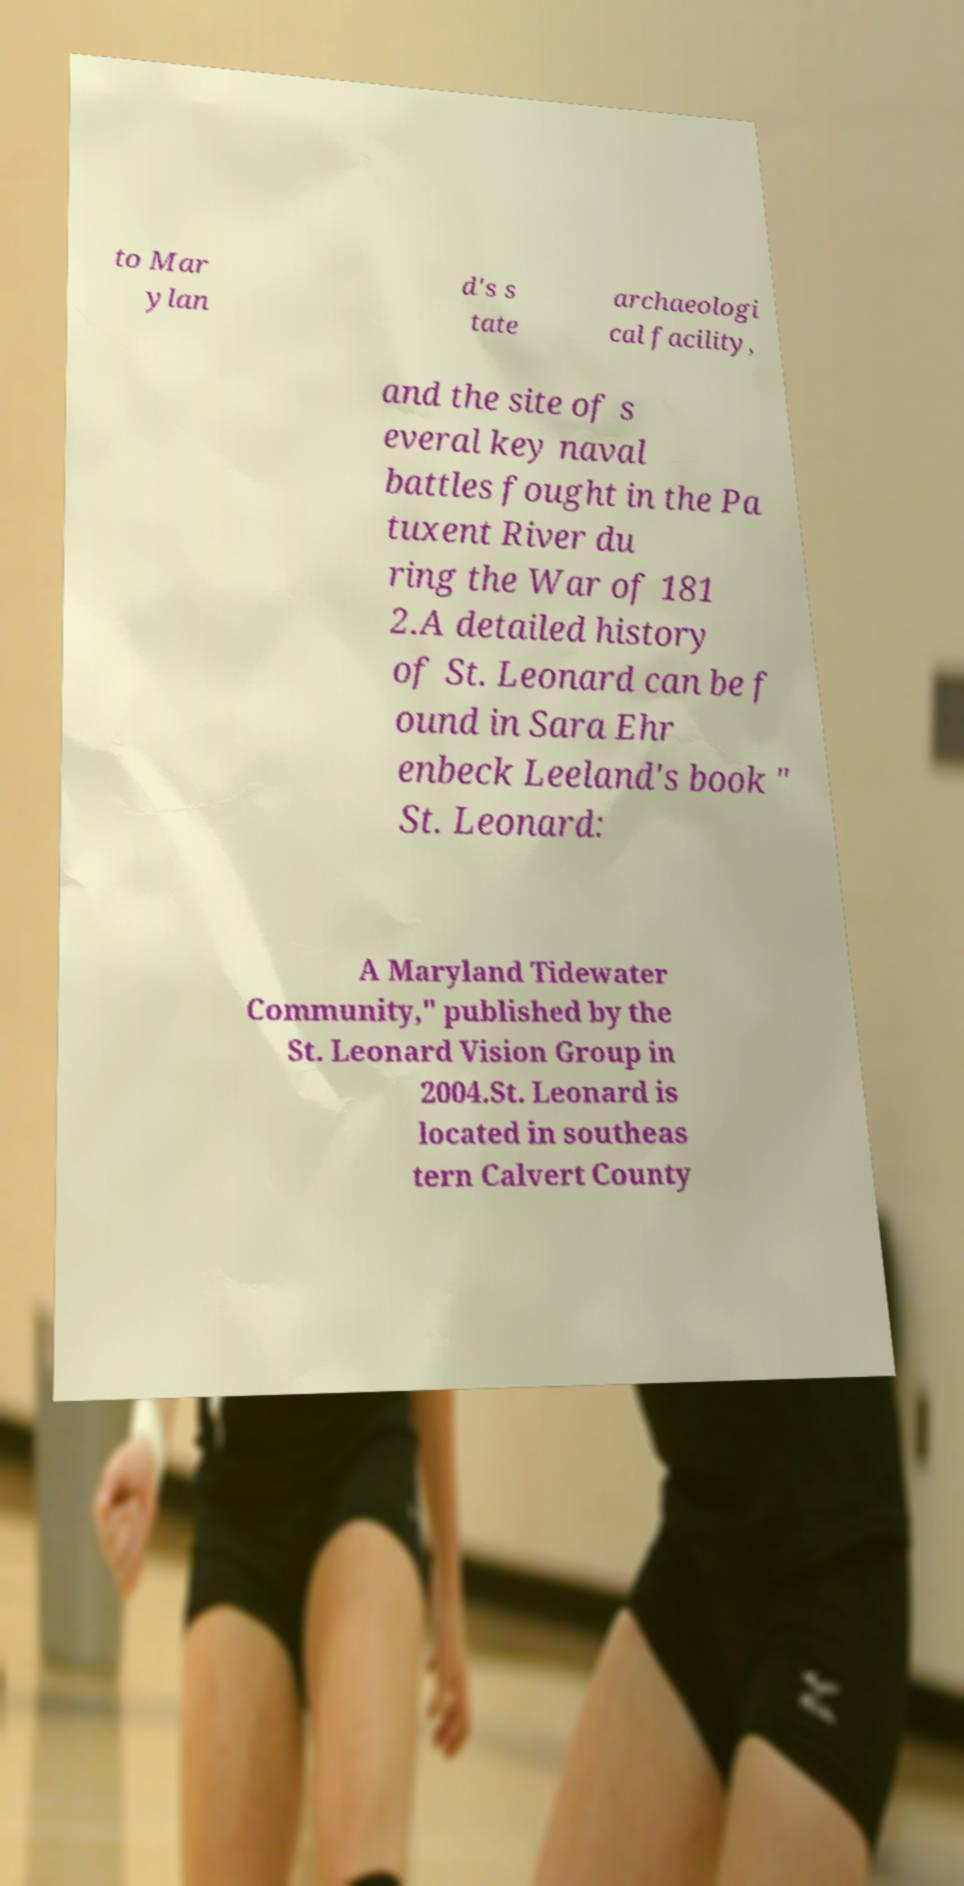Can you accurately transcribe the text from the provided image for me? to Mar ylan d's s tate archaeologi cal facility, and the site of s everal key naval battles fought in the Pa tuxent River du ring the War of 181 2.A detailed history of St. Leonard can be f ound in Sara Ehr enbeck Leeland's book " St. Leonard: A Maryland Tidewater Community," published by the St. Leonard Vision Group in 2004.St. Leonard is located in southeas tern Calvert County 